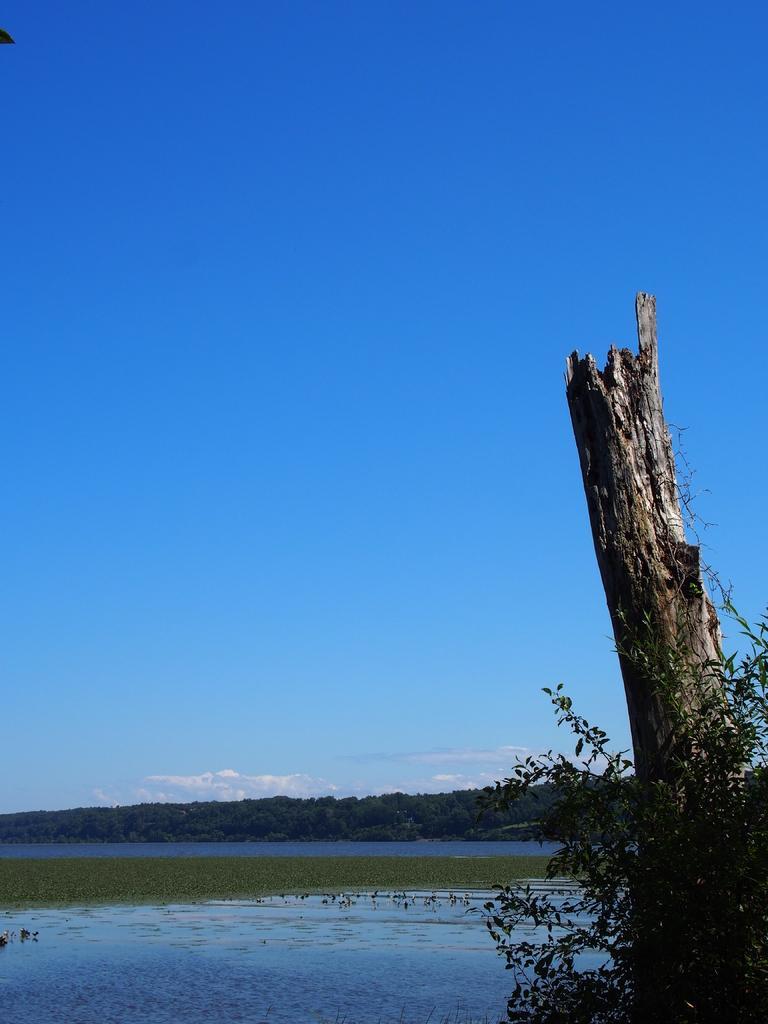Describe this image in one or two sentences. In this picture we can see water and few trees, in the background we can find clouds. 